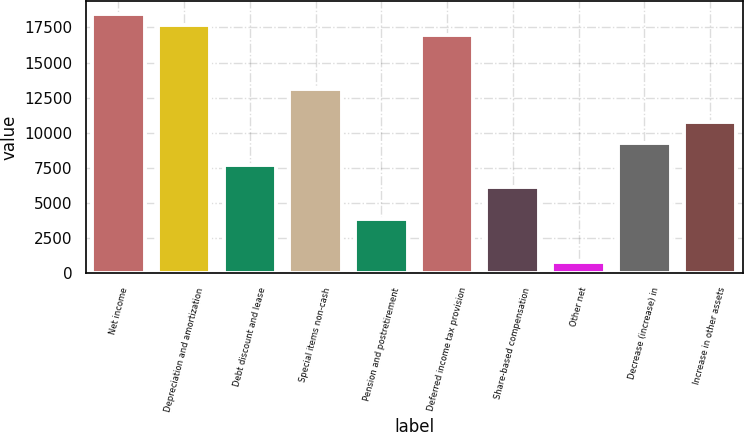Convert chart. <chart><loc_0><loc_0><loc_500><loc_500><bar_chart><fcel>Net income<fcel>Depreciation and amortization<fcel>Debt discount and lease<fcel>Special items non-cash<fcel>Pension and postretirement<fcel>Deferred income tax provision<fcel>Share-based compensation<fcel>Other net<fcel>Decrease (increase) in<fcel>Increase in other assets<nl><fcel>18475.4<fcel>17705.8<fcel>7701<fcel>13088.2<fcel>3853<fcel>16936.2<fcel>6161.8<fcel>774.6<fcel>9240.2<fcel>10779.4<nl></chart> 